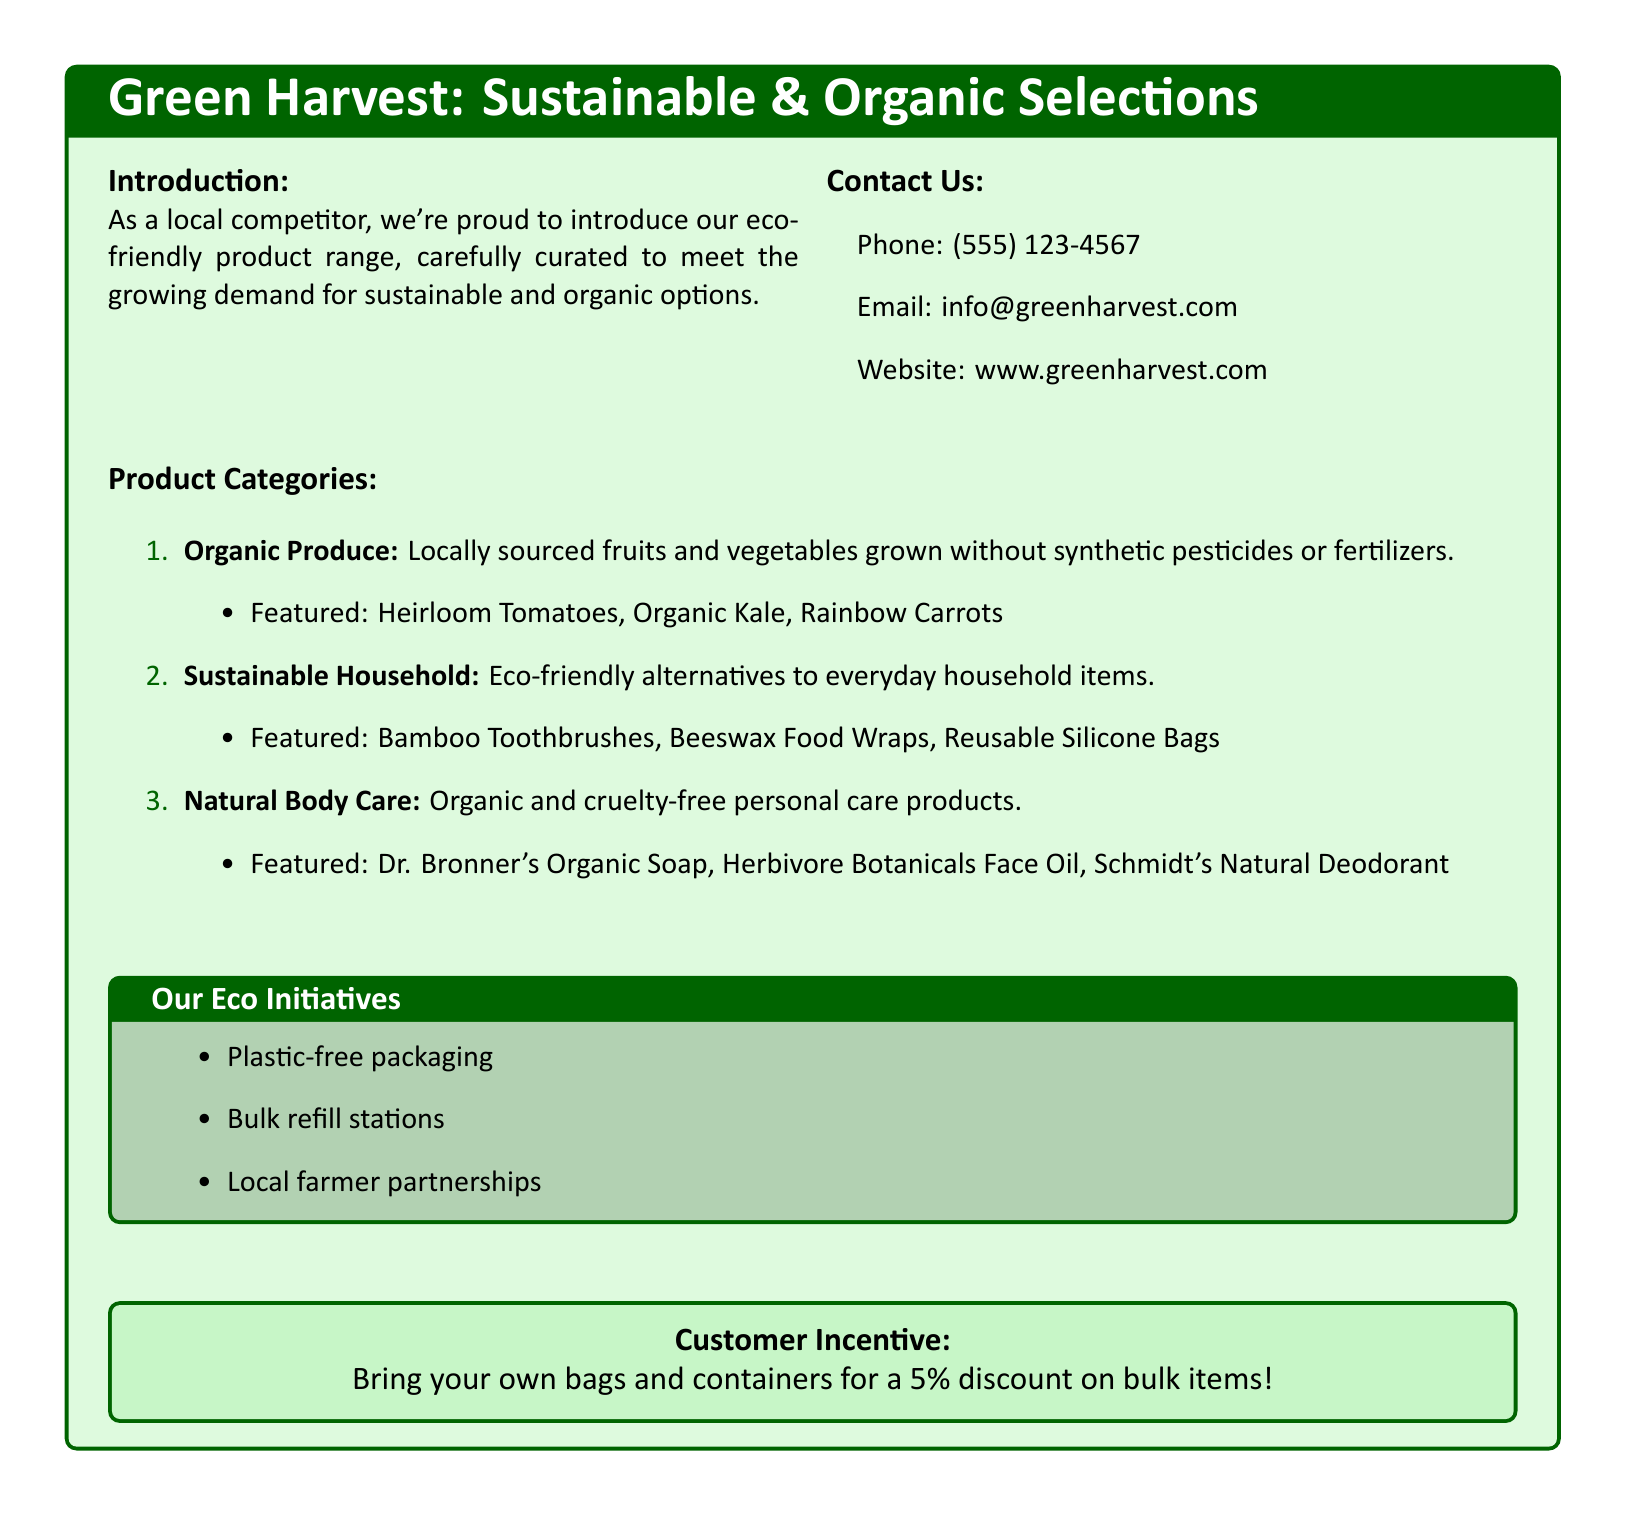What is the main title of the eco-friendly product section? The title displays the focus of the section on sustainable and organic products.
Answer: Green Harvest: Sustainable & Organic Selections What phone number can customers contact for inquiries? The document provides a contact number for customer questions.
Answer: (555) 123-4567 Which product category features Bamboo Toothbrushes? This requires understanding that specific products are listed under particular categories.
Answer: Sustainable Household What incentive do customers receive for bringing their own bags? The document mentions a specific discount offered to customers who practice eco-friendly behavior.
Answer: 5% discount Name one item from the Organic Produce category. Identifying specific items listed under the different product categories reflects the sustainable offerings.
Answer: Heirloom Tomatoes How many product categories are listed in the document? This question assesses the overall structure of the products offered in the catalog.
Answer: 3 What is one eco initiative mentioned in the document? This touches on the initiatives promoting sustainability and environmental responsibility.
Answer: Plastic-free packaging Which brand is featured in the Natural Body Care category? Identifying brands helps understand the quality and appeal of the products offered.
Answer: Dr. Bronner's Organic Soap 